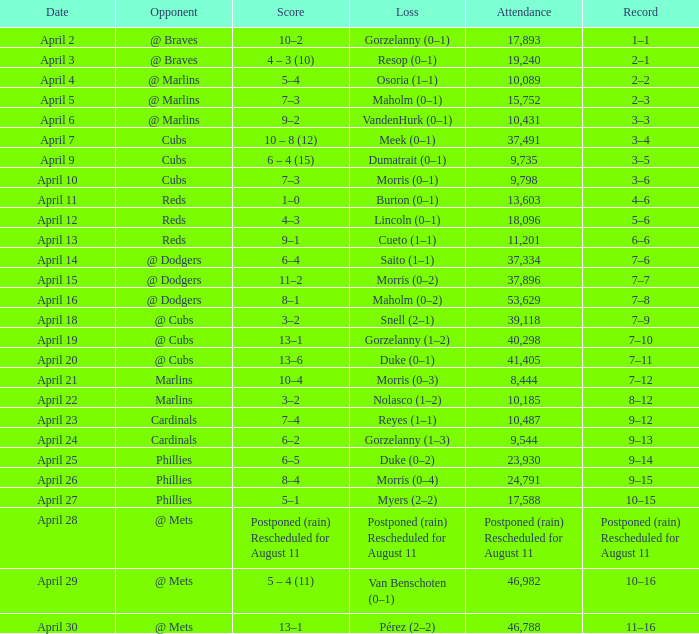What opponent had an attendance of 10,089? @ Marlins. 